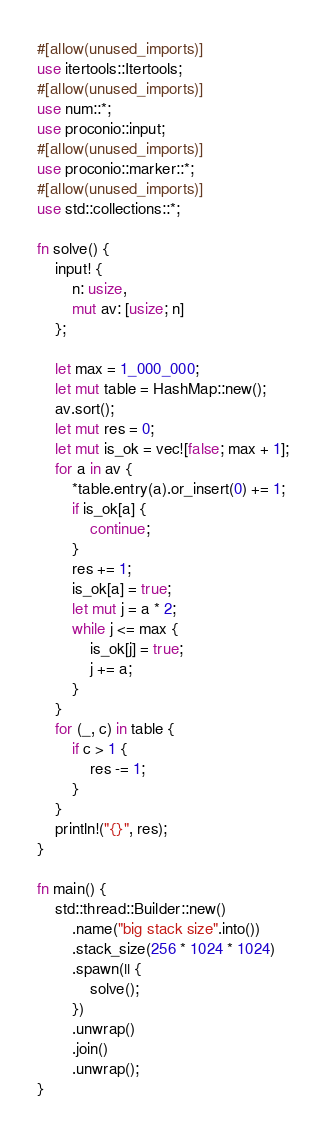<code> <loc_0><loc_0><loc_500><loc_500><_Rust_>#[allow(unused_imports)]
use itertools::Itertools;
#[allow(unused_imports)]
use num::*;
use proconio::input;
#[allow(unused_imports)]
use proconio::marker::*;
#[allow(unused_imports)]
use std::collections::*;

fn solve() {
    input! {
        n: usize,
        mut av: [usize; n]
    };

    let max = 1_000_000;
    let mut table = HashMap::new();
    av.sort();
    let mut res = 0;
    let mut is_ok = vec![false; max + 1];
    for a in av {
        *table.entry(a).or_insert(0) += 1;
        if is_ok[a] {
            continue;
        }
        res += 1;
        is_ok[a] = true;
        let mut j = a * 2;
        while j <= max {
            is_ok[j] = true;
            j += a;
        }
    }
    for (_, c) in table {
        if c > 1 {
            res -= 1;
        }
    }
    println!("{}", res);
}

fn main() {
    std::thread::Builder::new()
        .name("big stack size".into())
        .stack_size(256 * 1024 * 1024)
        .spawn(|| {
            solve();
        })
        .unwrap()
        .join()
        .unwrap();
}
</code> 